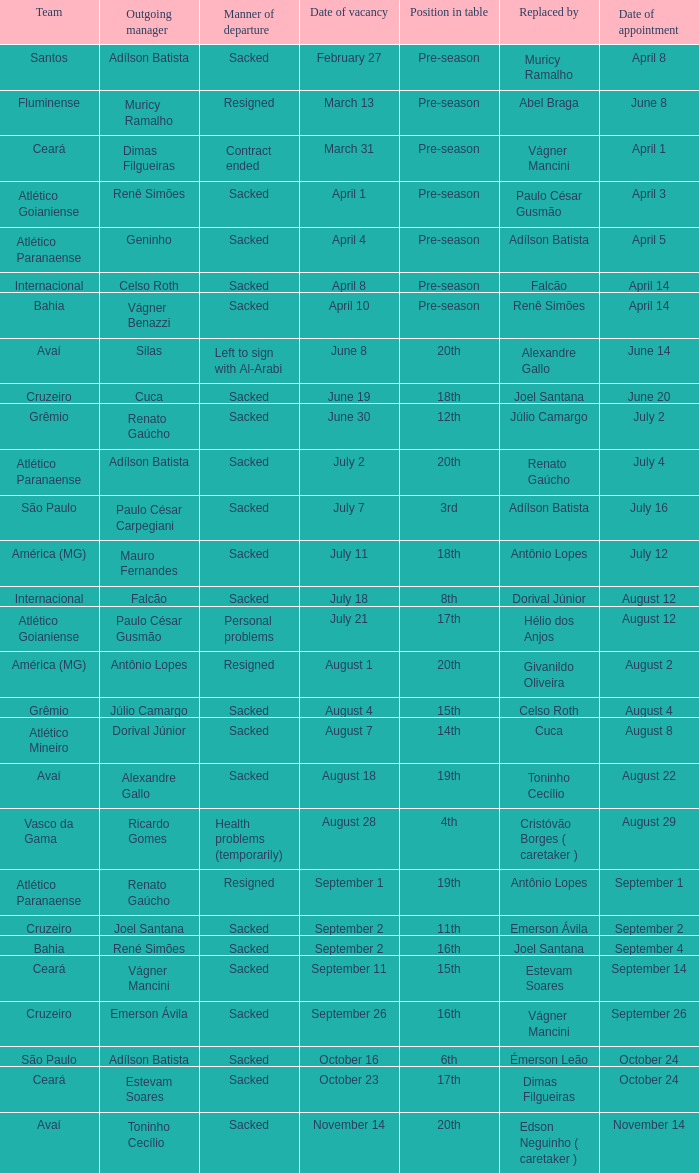Renato gaúcho was hired by which team? Atlético Paranaense. 